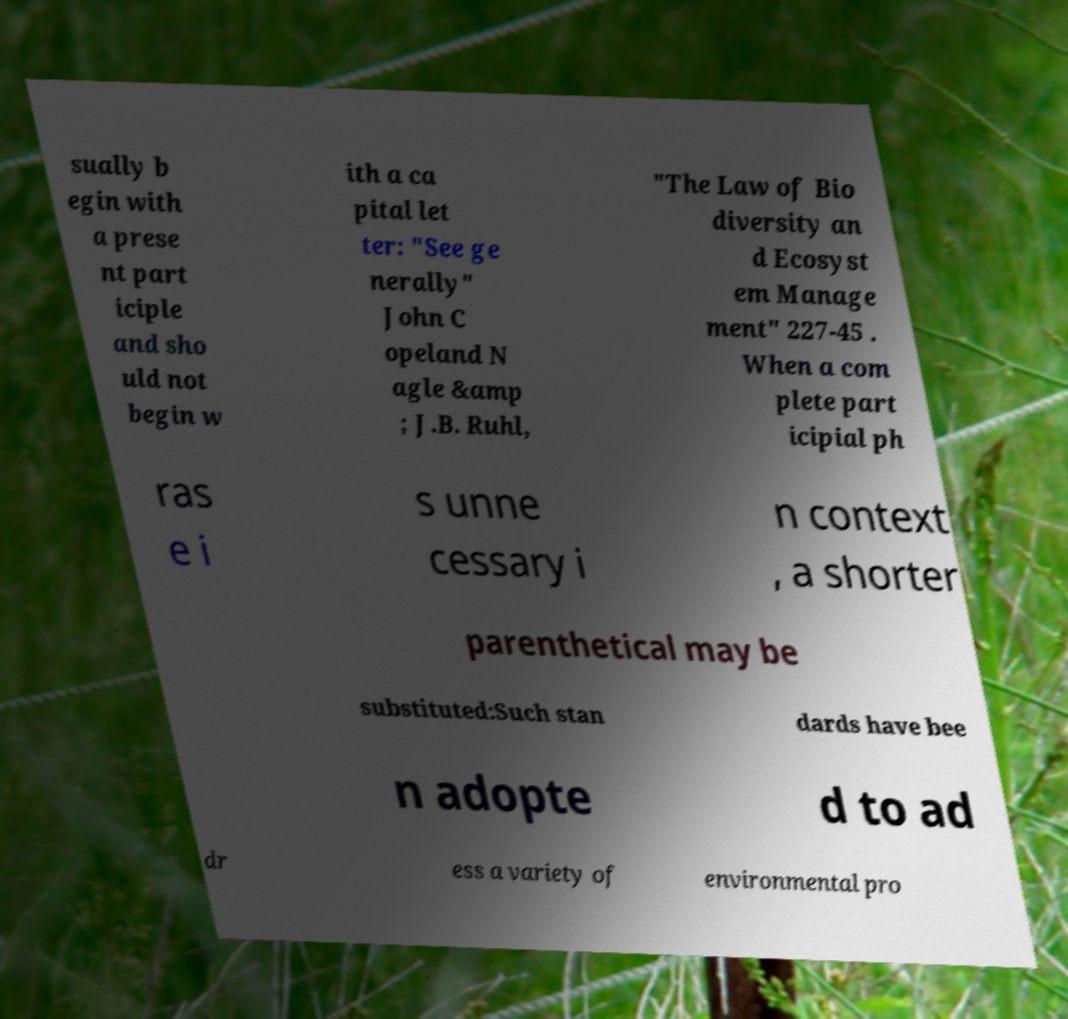Please identify and transcribe the text found in this image. sually b egin with a prese nt part iciple and sho uld not begin w ith a ca pital let ter: "See ge nerally" John C opeland N agle &amp ; J.B. Ruhl, "The Law of Bio diversity an d Ecosyst em Manage ment" 227-45 . When a com plete part icipial ph ras e i s unne cessary i n context , a shorter parenthetical may be substituted:Such stan dards have bee n adopte d to ad dr ess a variety of environmental pro 